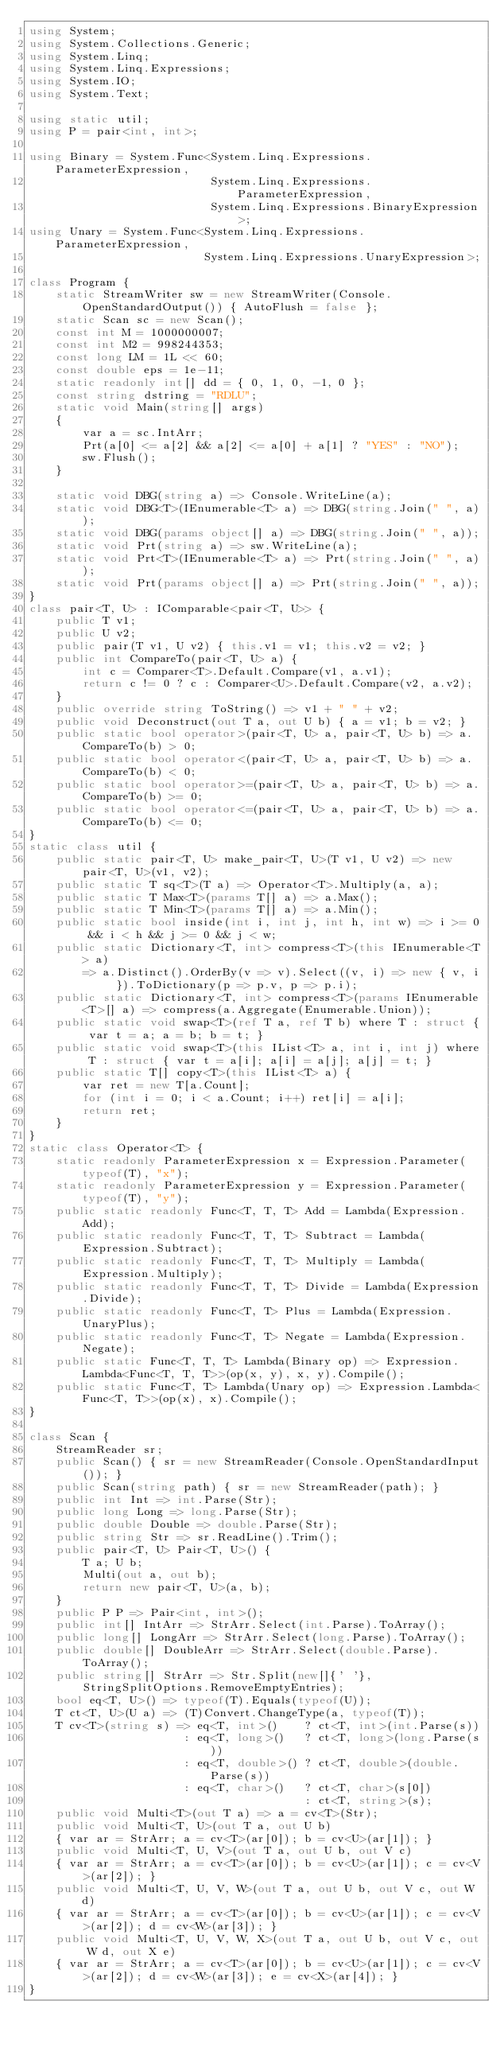<code> <loc_0><loc_0><loc_500><loc_500><_C#_>using System;
using System.Collections.Generic;
using System.Linq;
using System.Linq.Expressions;
using System.IO;
using System.Text;

using static util;
using P = pair<int, int>;

using Binary = System.Func<System.Linq.Expressions.ParameterExpression,
                           System.Linq.Expressions.ParameterExpression,
                           System.Linq.Expressions.BinaryExpression>;
using Unary = System.Func<System.Linq.Expressions.ParameterExpression,
                          System.Linq.Expressions.UnaryExpression>;

class Program {
    static StreamWriter sw = new StreamWriter(Console.OpenStandardOutput()) { AutoFlush = false };
    static Scan sc = new Scan();
    const int M = 1000000007;
    const int M2 = 998244353;
    const long LM = 1L << 60;
    const double eps = 1e-11;
    static readonly int[] dd = { 0, 1, 0, -1, 0 };
    const string dstring = "RDLU";
    static void Main(string[] args)
    {
        var a = sc.IntArr;
        Prt(a[0] <= a[2] && a[2] <= a[0] + a[1] ? "YES" : "NO");
        sw.Flush();
    }

    static void DBG(string a) => Console.WriteLine(a);
    static void DBG<T>(IEnumerable<T> a) => DBG(string.Join(" ", a));
    static void DBG(params object[] a) => DBG(string.Join(" ", a));
    static void Prt(string a) => sw.WriteLine(a);
    static void Prt<T>(IEnumerable<T> a) => Prt(string.Join(" ", a));
    static void Prt(params object[] a) => Prt(string.Join(" ", a));
}
class pair<T, U> : IComparable<pair<T, U>> {
    public T v1;
    public U v2;
    public pair(T v1, U v2) { this.v1 = v1; this.v2 = v2; }
    public int CompareTo(pair<T, U> a) {
        int c = Comparer<T>.Default.Compare(v1, a.v1);
        return c != 0 ? c : Comparer<U>.Default.Compare(v2, a.v2);
    }
    public override string ToString() => v1 + " " + v2;
    public void Deconstruct(out T a, out U b) { a = v1; b = v2; }
    public static bool operator>(pair<T, U> a, pair<T, U> b) => a.CompareTo(b) > 0;
    public static bool operator<(pair<T, U> a, pair<T, U> b) => a.CompareTo(b) < 0;
    public static bool operator>=(pair<T, U> a, pair<T, U> b) => a.CompareTo(b) >= 0;
    public static bool operator<=(pair<T, U> a, pair<T, U> b) => a.CompareTo(b) <= 0;
}
static class util {
    public static pair<T, U> make_pair<T, U>(T v1, U v2) => new pair<T, U>(v1, v2);
    public static T sq<T>(T a) => Operator<T>.Multiply(a, a);
    public static T Max<T>(params T[] a) => a.Max();
    public static T Min<T>(params T[] a) => a.Min();
    public static bool inside(int i, int j, int h, int w) => i >= 0 && i < h && j >= 0 && j < w;
    public static Dictionary<T, int> compress<T>(this IEnumerable<T> a)
        => a.Distinct().OrderBy(v => v).Select((v, i) => new { v, i }).ToDictionary(p => p.v, p => p.i);
    public static Dictionary<T, int> compress<T>(params IEnumerable<T>[] a) => compress(a.Aggregate(Enumerable.Union));
    public static void swap<T>(ref T a, ref T b) where T : struct { var t = a; a = b; b = t; }
    public static void swap<T>(this IList<T> a, int i, int j) where T : struct { var t = a[i]; a[i] = a[j]; a[j] = t; }
    public static T[] copy<T>(this IList<T> a) {
        var ret = new T[a.Count];
        for (int i = 0; i < a.Count; i++) ret[i] = a[i];
        return ret;
    }
}
static class Operator<T> {
    static readonly ParameterExpression x = Expression.Parameter(typeof(T), "x");
    static readonly ParameterExpression y = Expression.Parameter(typeof(T), "y");
    public static readonly Func<T, T, T> Add = Lambda(Expression.Add);
    public static readonly Func<T, T, T> Subtract = Lambda(Expression.Subtract);
    public static readonly Func<T, T, T> Multiply = Lambda(Expression.Multiply);
    public static readonly Func<T, T, T> Divide = Lambda(Expression.Divide);
    public static readonly Func<T, T> Plus = Lambda(Expression.UnaryPlus);
    public static readonly Func<T, T> Negate = Lambda(Expression.Negate);
    public static Func<T, T, T> Lambda(Binary op) => Expression.Lambda<Func<T, T, T>>(op(x, y), x, y).Compile();
    public static Func<T, T> Lambda(Unary op) => Expression.Lambda<Func<T, T>>(op(x), x).Compile();
}

class Scan {
    StreamReader sr;
    public Scan() { sr = new StreamReader(Console.OpenStandardInput()); }
    public Scan(string path) { sr = new StreamReader(path); }
    public int Int => int.Parse(Str);
    public long Long => long.Parse(Str);
    public double Double => double.Parse(Str);
    public string Str => sr.ReadLine().Trim();
    public pair<T, U> Pair<T, U>() {
        T a; U b;
        Multi(out a, out b);
        return new pair<T, U>(a, b);
    }
    public P P => Pair<int, int>();
    public int[] IntArr => StrArr.Select(int.Parse).ToArray();
    public long[] LongArr => StrArr.Select(long.Parse).ToArray();
    public double[] DoubleArr => StrArr.Select(double.Parse).ToArray();
    public string[] StrArr => Str.Split(new[]{' '}, StringSplitOptions.RemoveEmptyEntries);
    bool eq<T, U>() => typeof(T).Equals(typeof(U));
    T ct<T, U>(U a) => (T)Convert.ChangeType(a, typeof(T));
    T cv<T>(string s) => eq<T, int>()    ? ct<T, int>(int.Parse(s))
                       : eq<T, long>()   ? ct<T, long>(long.Parse(s))
                       : eq<T, double>() ? ct<T, double>(double.Parse(s))
                       : eq<T, char>()   ? ct<T, char>(s[0])
                                         : ct<T, string>(s);
    public void Multi<T>(out T a) => a = cv<T>(Str);
    public void Multi<T, U>(out T a, out U b)
    { var ar = StrArr; a = cv<T>(ar[0]); b = cv<U>(ar[1]); }
    public void Multi<T, U, V>(out T a, out U b, out V c)
    { var ar = StrArr; a = cv<T>(ar[0]); b = cv<U>(ar[1]); c = cv<V>(ar[2]); }
    public void Multi<T, U, V, W>(out T a, out U b, out V c, out W d)
    { var ar = StrArr; a = cv<T>(ar[0]); b = cv<U>(ar[1]); c = cv<V>(ar[2]); d = cv<W>(ar[3]); }
    public void Multi<T, U, V, W, X>(out T a, out U b, out V c, out W d, out X e)
    { var ar = StrArr; a = cv<T>(ar[0]); b = cv<U>(ar[1]); c = cv<V>(ar[2]); d = cv<W>(ar[3]); e = cv<X>(ar[4]); }
}
</code> 